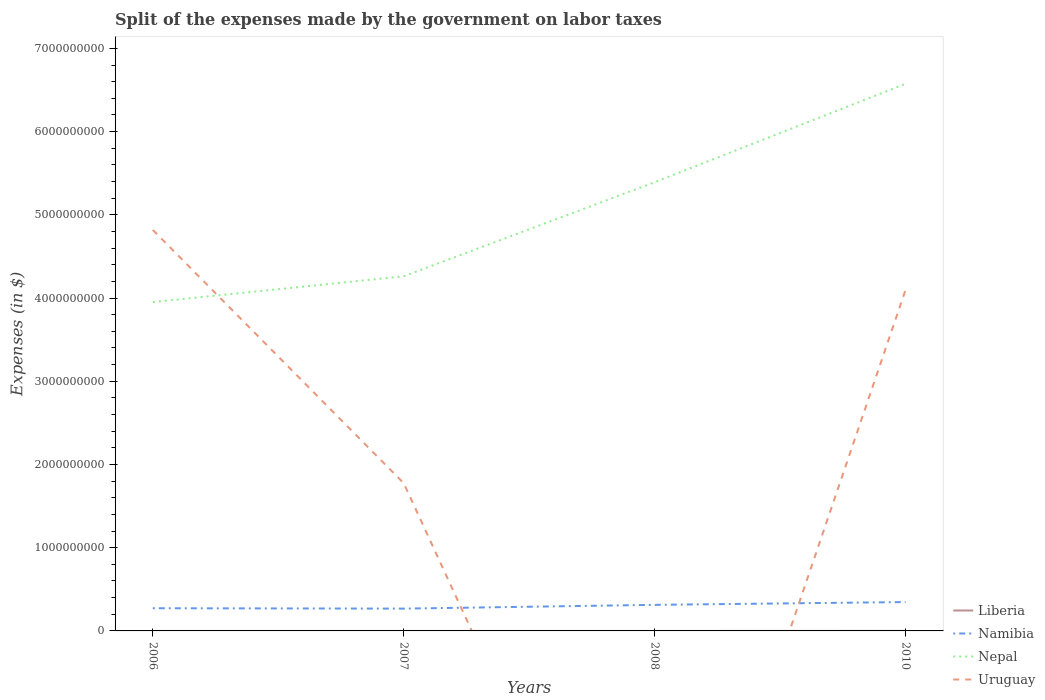How many different coloured lines are there?
Provide a short and direct response. 4. Does the line corresponding to Namibia intersect with the line corresponding to Liberia?
Offer a terse response. No. Is the number of lines equal to the number of legend labels?
Keep it short and to the point. No. Across all years, what is the maximum expenses made by the government on labor taxes in Nepal?
Your response must be concise. 3.95e+09. What is the total expenses made by the government on labor taxes in Namibia in the graph?
Make the answer very short. -7.44e+07. What is the difference between the highest and the second highest expenses made by the government on labor taxes in Liberia?
Your answer should be very brief. 1.79e+05. Is the expenses made by the government on labor taxes in Nepal strictly greater than the expenses made by the government on labor taxes in Namibia over the years?
Ensure brevity in your answer.  No. How many years are there in the graph?
Offer a very short reply. 4. What is the difference between two consecutive major ticks on the Y-axis?
Your answer should be very brief. 1.00e+09. Does the graph contain grids?
Provide a succinct answer. No. Where does the legend appear in the graph?
Offer a terse response. Bottom right. How many legend labels are there?
Keep it short and to the point. 4. What is the title of the graph?
Offer a terse response. Split of the expenses made by the government on labor taxes. What is the label or title of the Y-axis?
Ensure brevity in your answer.  Expenses (in $). What is the Expenses (in $) of Liberia in 2006?
Your answer should be compact. 4798.07. What is the Expenses (in $) of Namibia in 2006?
Ensure brevity in your answer.  2.73e+08. What is the Expenses (in $) of Nepal in 2006?
Ensure brevity in your answer.  3.95e+09. What is the Expenses (in $) in Uruguay in 2006?
Offer a terse response. 4.82e+09. What is the Expenses (in $) of Liberia in 2007?
Make the answer very short. 1.49e+04. What is the Expenses (in $) of Namibia in 2007?
Make the answer very short. 2.68e+08. What is the Expenses (in $) of Nepal in 2007?
Ensure brevity in your answer.  4.26e+09. What is the Expenses (in $) in Uruguay in 2007?
Provide a succinct answer. 1.77e+09. What is the Expenses (in $) of Liberia in 2008?
Your answer should be very brief. 2.34e+04. What is the Expenses (in $) of Namibia in 2008?
Your answer should be very brief. 3.13e+08. What is the Expenses (in $) in Nepal in 2008?
Keep it short and to the point. 5.39e+09. What is the Expenses (in $) in Liberia in 2010?
Your response must be concise. 1.84e+05. What is the Expenses (in $) of Namibia in 2010?
Provide a short and direct response. 3.47e+08. What is the Expenses (in $) in Nepal in 2010?
Provide a short and direct response. 6.57e+09. What is the Expenses (in $) of Uruguay in 2010?
Provide a succinct answer. 4.10e+09. Across all years, what is the maximum Expenses (in $) of Liberia?
Give a very brief answer. 1.84e+05. Across all years, what is the maximum Expenses (in $) in Namibia?
Ensure brevity in your answer.  3.47e+08. Across all years, what is the maximum Expenses (in $) in Nepal?
Provide a succinct answer. 6.57e+09. Across all years, what is the maximum Expenses (in $) in Uruguay?
Your answer should be very brief. 4.82e+09. Across all years, what is the minimum Expenses (in $) in Liberia?
Make the answer very short. 4798.07. Across all years, what is the minimum Expenses (in $) in Namibia?
Give a very brief answer. 2.68e+08. Across all years, what is the minimum Expenses (in $) of Nepal?
Make the answer very short. 3.95e+09. What is the total Expenses (in $) in Liberia in the graph?
Your response must be concise. 2.27e+05. What is the total Expenses (in $) of Namibia in the graph?
Your response must be concise. 1.20e+09. What is the total Expenses (in $) in Nepal in the graph?
Provide a succinct answer. 2.02e+1. What is the total Expenses (in $) of Uruguay in the graph?
Provide a succinct answer. 1.07e+1. What is the difference between the Expenses (in $) in Liberia in 2006 and that in 2007?
Your answer should be very brief. -1.01e+04. What is the difference between the Expenses (in $) in Namibia in 2006 and that in 2007?
Your answer should be compact. 4.53e+06. What is the difference between the Expenses (in $) in Nepal in 2006 and that in 2007?
Offer a terse response. -3.10e+08. What is the difference between the Expenses (in $) in Uruguay in 2006 and that in 2007?
Make the answer very short. 3.04e+09. What is the difference between the Expenses (in $) of Liberia in 2006 and that in 2008?
Provide a short and direct response. -1.86e+04. What is the difference between the Expenses (in $) of Namibia in 2006 and that in 2008?
Keep it short and to the point. -4.08e+07. What is the difference between the Expenses (in $) in Nepal in 2006 and that in 2008?
Your answer should be very brief. -1.44e+09. What is the difference between the Expenses (in $) in Liberia in 2006 and that in 2010?
Provide a succinct answer. -1.79e+05. What is the difference between the Expenses (in $) in Namibia in 2006 and that in 2010?
Provide a succinct answer. -7.44e+07. What is the difference between the Expenses (in $) in Nepal in 2006 and that in 2010?
Offer a terse response. -2.62e+09. What is the difference between the Expenses (in $) of Uruguay in 2006 and that in 2010?
Make the answer very short. 7.19e+08. What is the difference between the Expenses (in $) in Liberia in 2007 and that in 2008?
Provide a succinct answer. -8521.28. What is the difference between the Expenses (in $) in Namibia in 2007 and that in 2008?
Ensure brevity in your answer.  -4.53e+07. What is the difference between the Expenses (in $) in Nepal in 2007 and that in 2008?
Give a very brief answer. -1.13e+09. What is the difference between the Expenses (in $) in Liberia in 2007 and that in 2010?
Ensure brevity in your answer.  -1.69e+05. What is the difference between the Expenses (in $) in Namibia in 2007 and that in 2010?
Your answer should be very brief. -7.89e+07. What is the difference between the Expenses (in $) in Nepal in 2007 and that in 2010?
Keep it short and to the point. -2.31e+09. What is the difference between the Expenses (in $) in Uruguay in 2007 and that in 2010?
Your answer should be very brief. -2.32e+09. What is the difference between the Expenses (in $) in Liberia in 2008 and that in 2010?
Provide a short and direct response. -1.61e+05. What is the difference between the Expenses (in $) of Namibia in 2008 and that in 2010?
Provide a succinct answer. -3.36e+07. What is the difference between the Expenses (in $) in Nepal in 2008 and that in 2010?
Provide a short and direct response. -1.18e+09. What is the difference between the Expenses (in $) of Liberia in 2006 and the Expenses (in $) of Namibia in 2007?
Make the answer very short. -2.68e+08. What is the difference between the Expenses (in $) of Liberia in 2006 and the Expenses (in $) of Nepal in 2007?
Your answer should be very brief. -4.26e+09. What is the difference between the Expenses (in $) in Liberia in 2006 and the Expenses (in $) in Uruguay in 2007?
Keep it short and to the point. -1.77e+09. What is the difference between the Expenses (in $) of Namibia in 2006 and the Expenses (in $) of Nepal in 2007?
Your answer should be compact. -3.99e+09. What is the difference between the Expenses (in $) of Namibia in 2006 and the Expenses (in $) of Uruguay in 2007?
Ensure brevity in your answer.  -1.50e+09. What is the difference between the Expenses (in $) of Nepal in 2006 and the Expenses (in $) of Uruguay in 2007?
Your answer should be compact. 2.18e+09. What is the difference between the Expenses (in $) in Liberia in 2006 and the Expenses (in $) in Namibia in 2008?
Your answer should be very brief. -3.13e+08. What is the difference between the Expenses (in $) in Liberia in 2006 and the Expenses (in $) in Nepal in 2008?
Provide a short and direct response. -5.39e+09. What is the difference between the Expenses (in $) in Namibia in 2006 and the Expenses (in $) in Nepal in 2008?
Keep it short and to the point. -5.12e+09. What is the difference between the Expenses (in $) of Liberia in 2006 and the Expenses (in $) of Namibia in 2010?
Your response must be concise. -3.47e+08. What is the difference between the Expenses (in $) in Liberia in 2006 and the Expenses (in $) in Nepal in 2010?
Your answer should be very brief. -6.57e+09. What is the difference between the Expenses (in $) in Liberia in 2006 and the Expenses (in $) in Uruguay in 2010?
Ensure brevity in your answer.  -4.10e+09. What is the difference between the Expenses (in $) in Namibia in 2006 and the Expenses (in $) in Nepal in 2010?
Your response must be concise. -6.30e+09. What is the difference between the Expenses (in $) of Namibia in 2006 and the Expenses (in $) of Uruguay in 2010?
Offer a terse response. -3.83e+09. What is the difference between the Expenses (in $) of Nepal in 2006 and the Expenses (in $) of Uruguay in 2010?
Keep it short and to the point. -1.48e+08. What is the difference between the Expenses (in $) of Liberia in 2007 and the Expenses (in $) of Namibia in 2008?
Give a very brief answer. -3.13e+08. What is the difference between the Expenses (in $) of Liberia in 2007 and the Expenses (in $) of Nepal in 2008?
Offer a very short reply. -5.39e+09. What is the difference between the Expenses (in $) in Namibia in 2007 and the Expenses (in $) in Nepal in 2008?
Provide a short and direct response. -5.12e+09. What is the difference between the Expenses (in $) of Liberia in 2007 and the Expenses (in $) of Namibia in 2010?
Keep it short and to the point. -3.47e+08. What is the difference between the Expenses (in $) in Liberia in 2007 and the Expenses (in $) in Nepal in 2010?
Your answer should be compact. -6.57e+09. What is the difference between the Expenses (in $) of Liberia in 2007 and the Expenses (in $) of Uruguay in 2010?
Give a very brief answer. -4.10e+09. What is the difference between the Expenses (in $) in Namibia in 2007 and the Expenses (in $) in Nepal in 2010?
Your response must be concise. -6.31e+09. What is the difference between the Expenses (in $) of Namibia in 2007 and the Expenses (in $) of Uruguay in 2010?
Provide a succinct answer. -3.83e+09. What is the difference between the Expenses (in $) of Nepal in 2007 and the Expenses (in $) of Uruguay in 2010?
Offer a very short reply. 1.62e+08. What is the difference between the Expenses (in $) of Liberia in 2008 and the Expenses (in $) of Namibia in 2010?
Your answer should be compact. -3.47e+08. What is the difference between the Expenses (in $) in Liberia in 2008 and the Expenses (in $) in Nepal in 2010?
Keep it short and to the point. -6.57e+09. What is the difference between the Expenses (in $) in Liberia in 2008 and the Expenses (in $) in Uruguay in 2010?
Make the answer very short. -4.10e+09. What is the difference between the Expenses (in $) in Namibia in 2008 and the Expenses (in $) in Nepal in 2010?
Your response must be concise. -6.26e+09. What is the difference between the Expenses (in $) of Namibia in 2008 and the Expenses (in $) of Uruguay in 2010?
Ensure brevity in your answer.  -3.79e+09. What is the difference between the Expenses (in $) of Nepal in 2008 and the Expenses (in $) of Uruguay in 2010?
Ensure brevity in your answer.  1.29e+09. What is the average Expenses (in $) of Liberia per year?
Your answer should be compact. 5.68e+04. What is the average Expenses (in $) of Namibia per year?
Provide a succinct answer. 3.00e+08. What is the average Expenses (in $) in Nepal per year?
Your response must be concise. 5.04e+09. What is the average Expenses (in $) in Uruguay per year?
Ensure brevity in your answer.  2.67e+09. In the year 2006, what is the difference between the Expenses (in $) of Liberia and Expenses (in $) of Namibia?
Provide a succinct answer. -2.73e+08. In the year 2006, what is the difference between the Expenses (in $) of Liberia and Expenses (in $) of Nepal?
Your answer should be very brief. -3.95e+09. In the year 2006, what is the difference between the Expenses (in $) of Liberia and Expenses (in $) of Uruguay?
Offer a terse response. -4.82e+09. In the year 2006, what is the difference between the Expenses (in $) in Namibia and Expenses (in $) in Nepal?
Keep it short and to the point. -3.68e+09. In the year 2006, what is the difference between the Expenses (in $) of Namibia and Expenses (in $) of Uruguay?
Make the answer very short. -4.55e+09. In the year 2006, what is the difference between the Expenses (in $) in Nepal and Expenses (in $) in Uruguay?
Provide a short and direct response. -8.67e+08. In the year 2007, what is the difference between the Expenses (in $) in Liberia and Expenses (in $) in Namibia?
Your answer should be very brief. -2.68e+08. In the year 2007, what is the difference between the Expenses (in $) of Liberia and Expenses (in $) of Nepal?
Provide a succinct answer. -4.26e+09. In the year 2007, what is the difference between the Expenses (in $) in Liberia and Expenses (in $) in Uruguay?
Provide a short and direct response. -1.77e+09. In the year 2007, what is the difference between the Expenses (in $) in Namibia and Expenses (in $) in Nepal?
Your answer should be compact. -3.99e+09. In the year 2007, what is the difference between the Expenses (in $) of Namibia and Expenses (in $) of Uruguay?
Offer a very short reply. -1.51e+09. In the year 2007, what is the difference between the Expenses (in $) of Nepal and Expenses (in $) of Uruguay?
Your response must be concise. 2.49e+09. In the year 2008, what is the difference between the Expenses (in $) of Liberia and Expenses (in $) of Namibia?
Your answer should be compact. -3.13e+08. In the year 2008, what is the difference between the Expenses (in $) in Liberia and Expenses (in $) in Nepal?
Ensure brevity in your answer.  -5.39e+09. In the year 2008, what is the difference between the Expenses (in $) in Namibia and Expenses (in $) in Nepal?
Provide a succinct answer. -5.08e+09. In the year 2010, what is the difference between the Expenses (in $) of Liberia and Expenses (in $) of Namibia?
Ensure brevity in your answer.  -3.47e+08. In the year 2010, what is the difference between the Expenses (in $) of Liberia and Expenses (in $) of Nepal?
Provide a succinct answer. -6.57e+09. In the year 2010, what is the difference between the Expenses (in $) of Liberia and Expenses (in $) of Uruguay?
Provide a succinct answer. -4.10e+09. In the year 2010, what is the difference between the Expenses (in $) of Namibia and Expenses (in $) of Nepal?
Ensure brevity in your answer.  -6.23e+09. In the year 2010, what is the difference between the Expenses (in $) of Namibia and Expenses (in $) of Uruguay?
Ensure brevity in your answer.  -3.75e+09. In the year 2010, what is the difference between the Expenses (in $) of Nepal and Expenses (in $) of Uruguay?
Your response must be concise. 2.48e+09. What is the ratio of the Expenses (in $) in Liberia in 2006 to that in 2007?
Ensure brevity in your answer.  0.32. What is the ratio of the Expenses (in $) in Namibia in 2006 to that in 2007?
Offer a terse response. 1.02. What is the ratio of the Expenses (in $) in Nepal in 2006 to that in 2007?
Offer a very short reply. 0.93. What is the ratio of the Expenses (in $) in Uruguay in 2006 to that in 2007?
Offer a very short reply. 2.71. What is the ratio of the Expenses (in $) in Liberia in 2006 to that in 2008?
Your response must be concise. 0.2. What is the ratio of the Expenses (in $) of Namibia in 2006 to that in 2008?
Ensure brevity in your answer.  0.87. What is the ratio of the Expenses (in $) of Nepal in 2006 to that in 2008?
Provide a short and direct response. 0.73. What is the ratio of the Expenses (in $) of Liberia in 2006 to that in 2010?
Give a very brief answer. 0.03. What is the ratio of the Expenses (in $) of Namibia in 2006 to that in 2010?
Keep it short and to the point. 0.79. What is the ratio of the Expenses (in $) of Nepal in 2006 to that in 2010?
Your answer should be very brief. 0.6. What is the ratio of the Expenses (in $) of Uruguay in 2006 to that in 2010?
Offer a terse response. 1.18. What is the ratio of the Expenses (in $) of Liberia in 2007 to that in 2008?
Provide a short and direct response. 0.64. What is the ratio of the Expenses (in $) in Namibia in 2007 to that in 2008?
Your answer should be compact. 0.86. What is the ratio of the Expenses (in $) in Nepal in 2007 to that in 2008?
Keep it short and to the point. 0.79. What is the ratio of the Expenses (in $) in Liberia in 2007 to that in 2010?
Keep it short and to the point. 0.08. What is the ratio of the Expenses (in $) in Namibia in 2007 to that in 2010?
Ensure brevity in your answer.  0.77. What is the ratio of the Expenses (in $) in Nepal in 2007 to that in 2010?
Give a very brief answer. 0.65. What is the ratio of the Expenses (in $) of Uruguay in 2007 to that in 2010?
Your answer should be compact. 0.43. What is the ratio of the Expenses (in $) of Liberia in 2008 to that in 2010?
Offer a very short reply. 0.13. What is the ratio of the Expenses (in $) of Namibia in 2008 to that in 2010?
Provide a succinct answer. 0.9. What is the ratio of the Expenses (in $) in Nepal in 2008 to that in 2010?
Provide a short and direct response. 0.82. What is the difference between the highest and the second highest Expenses (in $) in Liberia?
Keep it short and to the point. 1.61e+05. What is the difference between the highest and the second highest Expenses (in $) of Namibia?
Your answer should be very brief. 3.36e+07. What is the difference between the highest and the second highest Expenses (in $) in Nepal?
Your answer should be compact. 1.18e+09. What is the difference between the highest and the second highest Expenses (in $) in Uruguay?
Give a very brief answer. 7.19e+08. What is the difference between the highest and the lowest Expenses (in $) in Liberia?
Provide a succinct answer. 1.79e+05. What is the difference between the highest and the lowest Expenses (in $) of Namibia?
Your response must be concise. 7.89e+07. What is the difference between the highest and the lowest Expenses (in $) of Nepal?
Provide a succinct answer. 2.62e+09. What is the difference between the highest and the lowest Expenses (in $) in Uruguay?
Your response must be concise. 4.82e+09. 